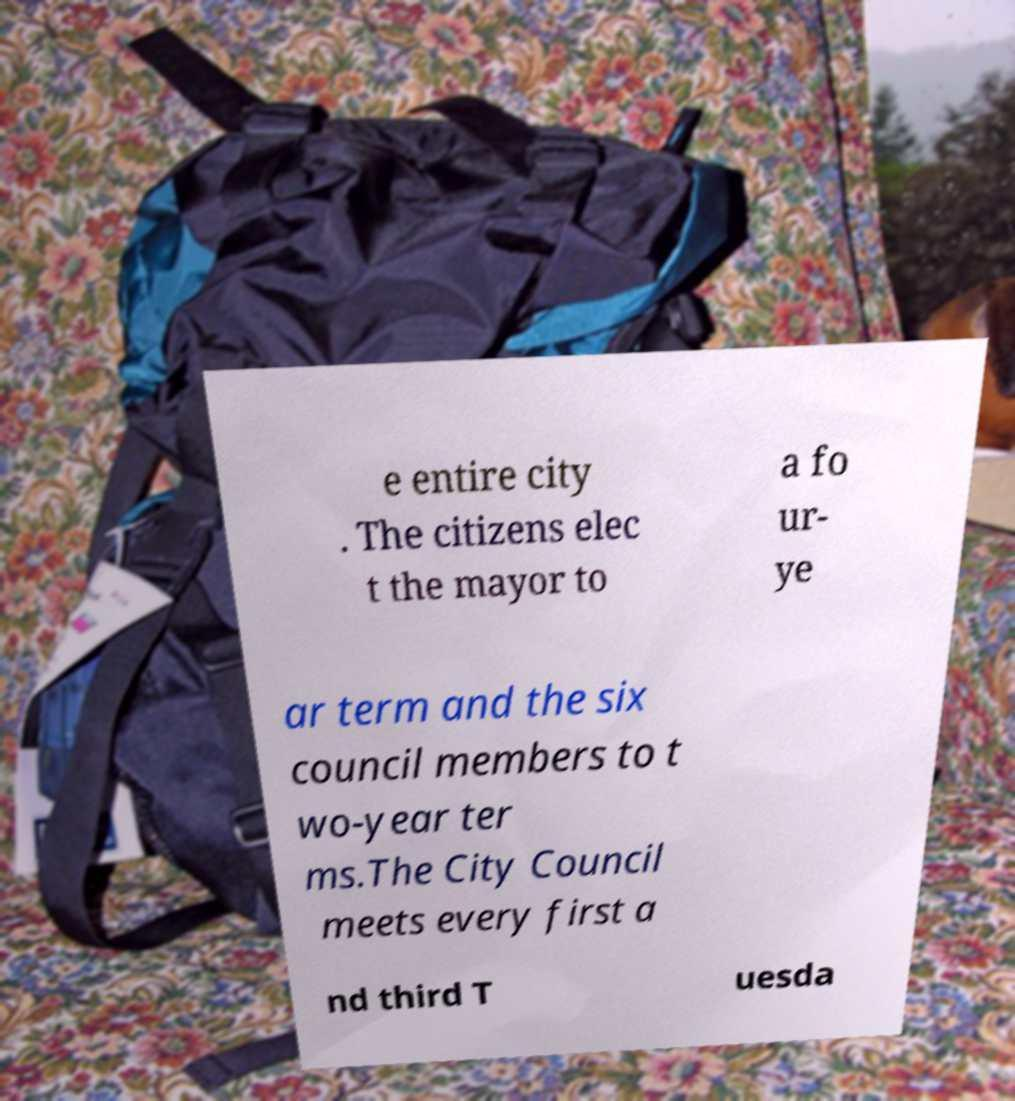Could you extract and type out the text from this image? e entire city . The citizens elec t the mayor to a fo ur- ye ar term and the six council members to t wo-year ter ms.The City Council meets every first a nd third T uesda 